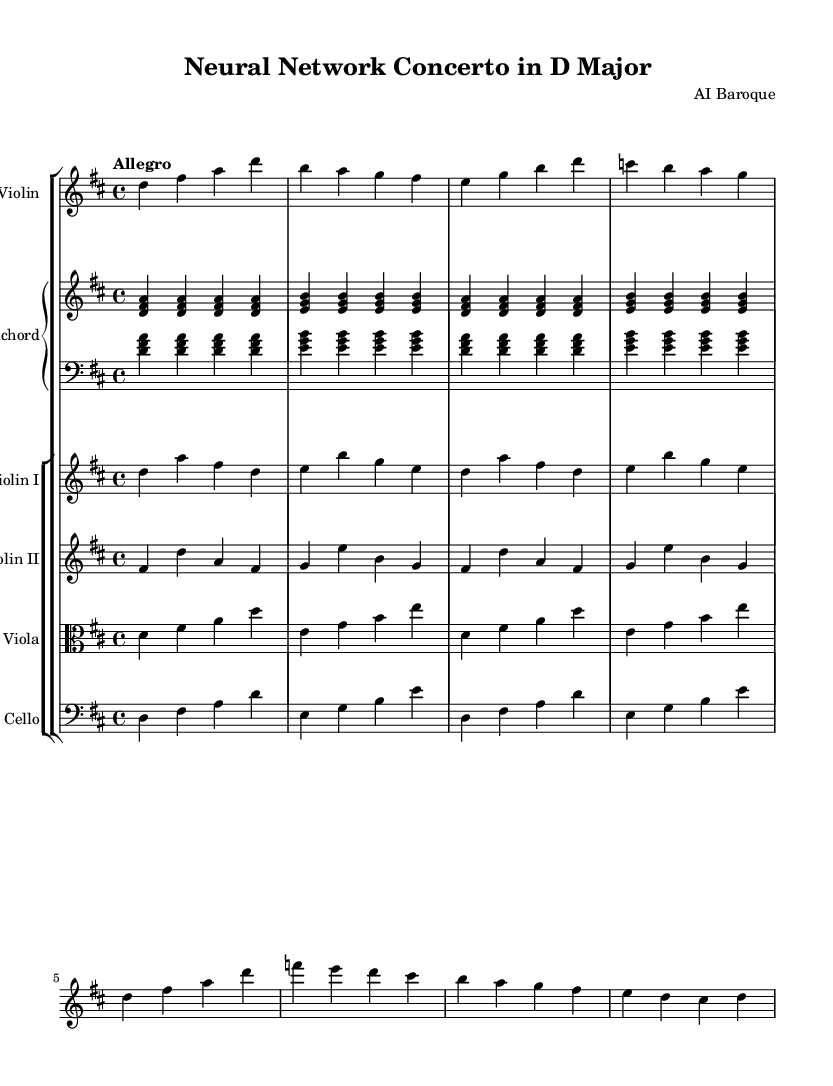What is the key signature of this music? The key signature is D major, indicated by two sharps, F# and C#. This can be identified by looking at the beginning of the staff where the sharps are notated.
Answer: D major What is the time signature of this piece? The time signature is 4/4, which appears at the beginning of the score. It indicates that there are four beats in each measure and the quarter note gets one beat.
Answer: 4/4 What is the tempo indication for this piece? The tempo indication is "Allegro" which means it should be played at a fast tempo. This is explicitly stated at the beginning of the score above the staff.
Answer: Allegro How many sections are in the violin solo? There are two sections in the violin solo: the ritornello and the solo episode. Each section can be identified by the specific phrases that are marked in the notation, with clear breaks between them.
Answer: 2 In what style is this concerto composed? This piece is composed in the Baroque style, recognizable by the use of contrasting sections and ornamentation typical of the period. The style can be identified by the specific instruments used and the overall structure of the music.
Answer: Baroque Which instruments accompany the solo violin? The accompanying instruments are the harpsichord, violin I, violin II, viola, and cello, which can be determined by the instrument names labeled in the staff groupings beneath the score.
Answer: Harpsichord, Violin I, Violin II, Viola, Cello What is the role of the harpsichord in the piece? The harpsichord functions as both a harmonic anchor and a continuo instrument, providing the chordal foundation and rhythmic support throughout the piece, which is typical in Baroque music. It is identified by the part labeled "Harpsichord" in the middle of the score.
Answer: Harmonic anchor 